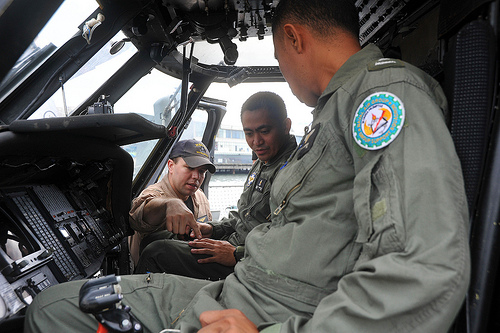<image>
Can you confirm if the patch is on the sleeve? Yes. Looking at the image, I can see the patch is positioned on top of the sleeve, with the sleeve providing support. 